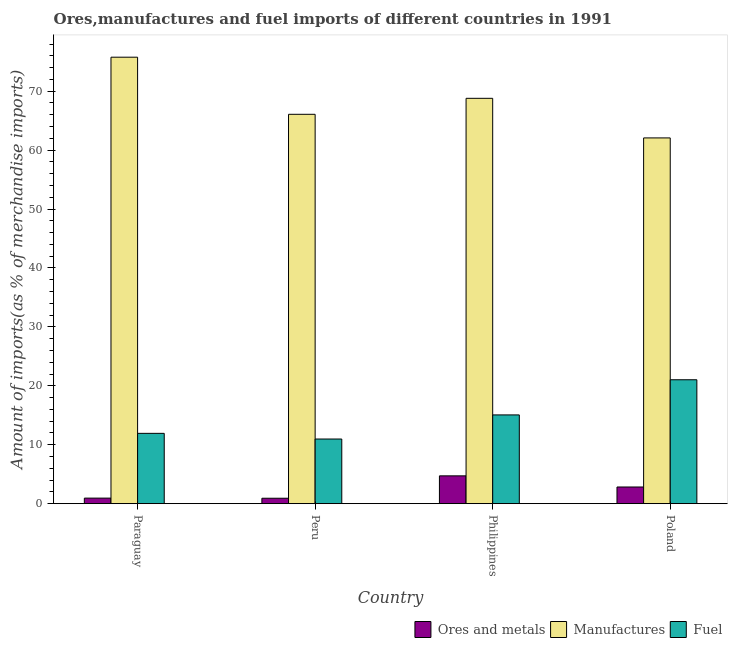Are the number of bars per tick equal to the number of legend labels?
Keep it short and to the point. Yes. How many bars are there on the 1st tick from the left?
Keep it short and to the point. 3. How many bars are there on the 2nd tick from the right?
Provide a succinct answer. 3. In how many cases, is the number of bars for a given country not equal to the number of legend labels?
Your response must be concise. 0. What is the percentage of ores and metals imports in Paraguay?
Give a very brief answer. 0.94. Across all countries, what is the maximum percentage of manufactures imports?
Your answer should be very brief. 75.77. Across all countries, what is the minimum percentage of manufactures imports?
Make the answer very short. 62.07. In which country was the percentage of ores and metals imports maximum?
Offer a very short reply. Philippines. In which country was the percentage of ores and metals imports minimum?
Keep it short and to the point. Peru. What is the total percentage of manufactures imports in the graph?
Give a very brief answer. 272.72. What is the difference between the percentage of manufactures imports in Peru and that in Poland?
Your answer should be very brief. 4. What is the difference between the percentage of ores and metals imports in Paraguay and the percentage of manufactures imports in Poland?
Keep it short and to the point. -61.13. What is the average percentage of manufactures imports per country?
Provide a short and direct response. 68.18. What is the difference between the percentage of ores and metals imports and percentage of manufactures imports in Poland?
Give a very brief answer. -59.24. In how many countries, is the percentage of ores and metals imports greater than 10 %?
Provide a succinct answer. 0. What is the ratio of the percentage of ores and metals imports in Philippines to that in Poland?
Ensure brevity in your answer.  1.67. Is the percentage of fuel imports in Paraguay less than that in Peru?
Provide a short and direct response. No. Is the difference between the percentage of ores and metals imports in Peru and Poland greater than the difference between the percentage of manufactures imports in Peru and Poland?
Your answer should be compact. No. What is the difference between the highest and the second highest percentage of ores and metals imports?
Ensure brevity in your answer.  1.89. What is the difference between the highest and the lowest percentage of fuel imports?
Provide a short and direct response. 10.06. What does the 2nd bar from the left in Philippines represents?
Provide a short and direct response. Manufactures. What does the 3rd bar from the right in Poland represents?
Provide a succinct answer. Ores and metals. Is it the case that in every country, the sum of the percentage of ores and metals imports and percentage of manufactures imports is greater than the percentage of fuel imports?
Make the answer very short. Yes. How many bars are there?
Offer a very short reply. 12. Does the graph contain any zero values?
Provide a succinct answer. No. Does the graph contain grids?
Offer a very short reply. No. Where does the legend appear in the graph?
Offer a very short reply. Bottom right. How many legend labels are there?
Your answer should be compact. 3. How are the legend labels stacked?
Your answer should be compact. Horizontal. What is the title of the graph?
Keep it short and to the point. Ores,manufactures and fuel imports of different countries in 1991. What is the label or title of the Y-axis?
Offer a very short reply. Amount of imports(as % of merchandise imports). What is the Amount of imports(as % of merchandise imports) of Ores and metals in Paraguay?
Keep it short and to the point. 0.94. What is the Amount of imports(as % of merchandise imports) in Manufactures in Paraguay?
Make the answer very short. 75.77. What is the Amount of imports(as % of merchandise imports) of Fuel in Paraguay?
Give a very brief answer. 11.93. What is the Amount of imports(as % of merchandise imports) of Ores and metals in Peru?
Provide a succinct answer. 0.92. What is the Amount of imports(as % of merchandise imports) of Manufactures in Peru?
Keep it short and to the point. 66.08. What is the Amount of imports(as % of merchandise imports) of Fuel in Peru?
Offer a terse response. 10.97. What is the Amount of imports(as % of merchandise imports) of Ores and metals in Philippines?
Make the answer very short. 4.72. What is the Amount of imports(as % of merchandise imports) in Manufactures in Philippines?
Your response must be concise. 68.79. What is the Amount of imports(as % of merchandise imports) of Fuel in Philippines?
Your answer should be compact. 15.06. What is the Amount of imports(as % of merchandise imports) of Ores and metals in Poland?
Keep it short and to the point. 2.83. What is the Amount of imports(as % of merchandise imports) in Manufactures in Poland?
Your answer should be compact. 62.07. What is the Amount of imports(as % of merchandise imports) of Fuel in Poland?
Make the answer very short. 21.03. Across all countries, what is the maximum Amount of imports(as % of merchandise imports) of Ores and metals?
Keep it short and to the point. 4.72. Across all countries, what is the maximum Amount of imports(as % of merchandise imports) in Manufactures?
Your answer should be very brief. 75.77. Across all countries, what is the maximum Amount of imports(as % of merchandise imports) in Fuel?
Give a very brief answer. 21.03. Across all countries, what is the minimum Amount of imports(as % of merchandise imports) in Ores and metals?
Offer a terse response. 0.92. Across all countries, what is the minimum Amount of imports(as % of merchandise imports) of Manufactures?
Make the answer very short. 62.07. Across all countries, what is the minimum Amount of imports(as % of merchandise imports) of Fuel?
Keep it short and to the point. 10.97. What is the total Amount of imports(as % of merchandise imports) of Ores and metals in the graph?
Ensure brevity in your answer.  9.41. What is the total Amount of imports(as % of merchandise imports) in Manufactures in the graph?
Give a very brief answer. 272.72. What is the total Amount of imports(as % of merchandise imports) of Fuel in the graph?
Ensure brevity in your answer.  58.99. What is the difference between the Amount of imports(as % of merchandise imports) of Ores and metals in Paraguay and that in Peru?
Offer a terse response. 0.02. What is the difference between the Amount of imports(as % of merchandise imports) of Manufactures in Paraguay and that in Peru?
Ensure brevity in your answer.  9.69. What is the difference between the Amount of imports(as % of merchandise imports) in Fuel in Paraguay and that in Peru?
Offer a terse response. 0.96. What is the difference between the Amount of imports(as % of merchandise imports) in Ores and metals in Paraguay and that in Philippines?
Keep it short and to the point. -3.78. What is the difference between the Amount of imports(as % of merchandise imports) in Manufactures in Paraguay and that in Philippines?
Make the answer very short. 6.98. What is the difference between the Amount of imports(as % of merchandise imports) in Fuel in Paraguay and that in Philippines?
Your answer should be very brief. -3.13. What is the difference between the Amount of imports(as % of merchandise imports) of Ores and metals in Paraguay and that in Poland?
Your response must be concise. -1.89. What is the difference between the Amount of imports(as % of merchandise imports) in Manufactures in Paraguay and that in Poland?
Offer a very short reply. 13.7. What is the difference between the Amount of imports(as % of merchandise imports) of Fuel in Paraguay and that in Poland?
Give a very brief answer. -9.1. What is the difference between the Amount of imports(as % of merchandise imports) in Ores and metals in Peru and that in Philippines?
Offer a very short reply. -3.8. What is the difference between the Amount of imports(as % of merchandise imports) of Manufactures in Peru and that in Philippines?
Ensure brevity in your answer.  -2.71. What is the difference between the Amount of imports(as % of merchandise imports) of Fuel in Peru and that in Philippines?
Ensure brevity in your answer.  -4.09. What is the difference between the Amount of imports(as % of merchandise imports) in Ores and metals in Peru and that in Poland?
Offer a very short reply. -1.91. What is the difference between the Amount of imports(as % of merchandise imports) in Manufactures in Peru and that in Poland?
Provide a succinct answer. 4. What is the difference between the Amount of imports(as % of merchandise imports) in Fuel in Peru and that in Poland?
Your response must be concise. -10.06. What is the difference between the Amount of imports(as % of merchandise imports) in Ores and metals in Philippines and that in Poland?
Make the answer very short. 1.89. What is the difference between the Amount of imports(as % of merchandise imports) in Manufactures in Philippines and that in Poland?
Offer a terse response. 6.72. What is the difference between the Amount of imports(as % of merchandise imports) of Fuel in Philippines and that in Poland?
Keep it short and to the point. -5.97. What is the difference between the Amount of imports(as % of merchandise imports) of Ores and metals in Paraguay and the Amount of imports(as % of merchandise imports) of Manufactures in Peru?
Make the answer very short. -65.14. What is the difference between the Amount of imports(as % of merchandise imports) in Ores and metals in Paraguay and the Amount of imports(as % of merchandise imports) in Fuel in Peru?
Provide a short and direct response. -10.03. What is the difference between the Amount of imports(as % of merchandise imports) in Manufactures in Paraguay and the Amount of imports(as % of merchandise imports) in Fuel in Peru?
Keep it short and to the point. 64.8. What is the difference between the Amount of imports(as % of merchandise imports) of Ores and metals in Paraguay and the Amount of imports(as % of merchandise imports) of Manufactures in Philippines?
Your answer should be very brief. -67.85. What is the difference between the Amount of imports(as % of merchandise imports) in Ores and metals in Paraguay and the Amount of imports(as % of merchandise imports) in Fuel in Philippines?
Make the answer very short. -14.12. What is the difference between the Amount of imports(as % of merchandise imports) of Manufactures in Paraguay and the Amount of imports(as % of merchandise imports) of Fuel in Philippines?
Give a very brief answer. 60.71. What is the difference between the Amount of imports(as % of merchandise imports) of Ores and metals in Paraguay and the Amount of imports(as % of merchandise imports) of Manufactures in Poland?
Make the answer very short. -61.13. What is the difference between the Amount of imports(as % of merchandise imports) in Ores and metals in Paraguay and the Amount of imports(as % of merchandise imports) in Fuel in Poland?
Offer a terse response. -20.09. What is the difference between the Amount of imports(as % of merchandise imports) of Manufactures in Paraguay and the Amount of imports(as % of merchandise imports) of Fuel in Poland?
Your answer should be very brief. 54.74. What is the difference between the Amount of imports(as % of merchandise imports) in Ores and metals in Peru and the Amount of imports(as % of merchandise imports) in Manufactures in Philippines?
Offer a very short reply. -67.88. What is the difference between the Amount of imports(as % of merchandise imports) in Ores and metals in Peru and the Amount of imports(as % of merchandise imports) in Fuel in Philippines?
Provide a succinct answer. -14.14. What is the difference between the Amount of imports(as % of merchandise imports) in Manufactures in Peru and the Amount of imports(as % of merchandise imports) in Fuel in Philippines?
Ensure brevity in your answer.  51.02. What is the difference between the Amount of imports(as % of merchandise imports) in Ores and metals in Peru and the Amount of imports(as % of merchandise imports) in Manufactures in Poland?
Give a very brief answer. -61.16. What is the difference between the Amount of imports(as % of merchandise imports) in Ores and metals in Peru and the Amount of imports(as % of merchandise imports) in Fuel in Poland?
Your answer should be very brief. -20.11. What is the difference between the Amount of imports(as % of merchandise imports) of Manufactures in Peru and the Amount of imports(as % of merchandise imports) of Fuel in Poland?
Offer a very short reply. 45.05. What is the difference between the Amount of imports(as % of merchandise imports) of Ores and metals in Philippines and the Amount of imports(as % of merchandise imports) of Manufactures in Poland?
Give a very brief answer. -57.35. What is the difference between the Amount of imports(as % of merchandise imports) of Ores and metals in Philippines and the Amount of imports(as % of merchandise imports) of Fuel in Poland?
Offer a very short reply. -16.31. What is the difference between the Amount of imports(as % of merchandise imports) in Manufactures in Philippines and the Amount of imports(as % of merchandise imports) in Fuel in Poland?
Give a very brief answer. 47.76. What is the average Amount of imports(as % of merchandise imports) in Ores and metals per country?
Provide a succinct answer. 2.35. What is the average Amount of imports(as % of merchandise imports) of Manufactures per country?
Your answer should be compact. 68.18. What is the average Amount of imports(as % of merchandise imports) in Fuel per country?
Give a very brief answer. 14.75. What is the difference between the Amount of imports(as % of merchandise imports) of Ores and metals and Amount of imports(as % of merchandise imports) of Manufactures in Paraguay?
Offer a very short reply. -74.83. What is the difference between the Amount of imports(as % of merchandise imports) of Ores and metals and Amount of imports(as % of merchandise imports) of Fuel in Paraguay?
Offer a very short reply. -10.99. What is the difference between the Amount of imports(as % of merchandise imports) of Manufactures and Amount of imports(as % of merchandise imports) of Fuel in Paraguay?
Keep it short and to the point. 63.84. What is the difference between the Amount of imports(as % of merchandise imports) of Ores and metals and Amount of imports(as % of merchandise imports) of Manufactures in Peru?
Ensure brevity in your answer.  -65.16. What is the difference between the Amount of imports(as % of merchandise imports) in Ores and metals and Amount of imports(as % of merchandise imports) in Fuel in Peru?
Your response must be concise. -10.05. What is the difference between the Amount of imports(as % of merchandise imports) of Manufactures and Amount of imports(as % of merchandise imports) of Fuel in Peru?
Your response must be concise. 55.11. What is the difference between the Amount of imports(as % of merchandise imports) of Ores and metals and Amount of imports(as % of merchandise imports) of Manufactures in Philippines?
Offer a very short reply. -64.07. What is the difference between the Amount of imports(as % of merchandise imports) in Ores and metals and Amount of imports(as % of merchandise imports) in Fuel in Philippines?
Ensure brevity in your answer.  -10.34. What is the difference between the Amount of imports(as % of merchandise imports) in Manufactures and Amount of imports(as % of merchandise imports) in Fuel in Philippines?
Provide a succinct answer. 53.73. What is the difference between the Amount of imports(as % of merchandise imports) of Ores and metals and Amount of imports(as % of merchandise imports) of Manufactures in Poland?
Give a very brief answer. -59.24. What is the difference between the Amount of imports(as % of merchandise imports) in Ores and metals and Amount of imports(as % of merchandise imports) in Fuel in Poland?
Provide a succinct answer. -18.2. What is the difference between the Amount of imports(as % of merchandise imports) of Manufactures and Amount of imports(as % of merchandise imports) of Fuel in Poland?
Ensure brevity in your answer.  41.04. What is the ratio of the Amount of imports(as % of merchandise imports) of Ores and metals in Paraguay to that in Peru?
Your answer should be compact. 1.02. What is the ratio of the Amount of imports(as % of merchandise imports) in Manufactures in Paraguay to that in Peru?
Offer a terse response. 1.15. What is the ratio of the Amount of imports(as % of merchandise imports) of Fuel in Paraguay to that in Peru?
Your response must be concise. 1.09. What is the ratio of the Amount of imports(as % of merchandise imports) in Ores and metals in Paraguay to that in Philippines?
Offer a terse response. 0.2. What is the ratio of the Amount of imports(as % of merchandise imports) in Manufactures in Paraguay to that in Philippines?
Ensure brevity in your answer.  1.1. What is the ratio of the Amount of imports(as % of merchandise imports) of Fuel in Paraguay to that in Philippines?
Your response must be concise. 0.79. What is the ratio of the Amount of imports(as % of merchandise imports) of Ores and metals in Paraguay to that in Poland?
Ensure brevity in your answer.  0.33. What is the ratio of the Amount of imports(as % of merchandise imports) of Manufactures in Paraguay to that in Poland?
Ensure brevity in your answer.  1.22. What is the ratio of the Amount of imports(as % of merchandise imports) in Fuel in Paraguay to that in Poland?
Your answer should be compact. 0.57. What is the ratio of the Amount of imports(as % of merchandise imports) in Ores and metals in Peru to that in Philippines?
Ensure brevity in your answer.  0.19. What is the ratio of the Amount of imports(as % of merchandise imports) in Manufactures in Peru to that in Philippines?
Offer a terse response. 0.96. What is the ratio of the Amount of imports(as % of merchandise imports) in Fuel in Peru to that in Philippines?
Provide a short and direct response. 0.73. What is the ratio of the Amount of imports(as % of merchandise imports) in Ores and metals in Peru to that in Poland?
Give a very brief answer. 0.32. What is the ratio of the Amount of imports(as % of merchandise imports) in Manufactures in Peru to that in Poland?
Provide a succinct answer. 1.06. What is the ratio of the Amount of imports(as % of merchandise imports) in Fuel in Peru to that in Poland?
Give a very brief answer. 0.52. What is the ratio of the Amount of imports(as % of merchandise imports) in Ores and metals in Philippines to that in Poland?
Provide a short and direct response. 1.67. What is the ratio of the Amount of imports(as % of merchandise imports) in Manufactures in Philippines to that in Poland?
Your response must be concise. 1.11. What is the ratio of the Amount of imports(as % of merchandise imports) in Fuel in Philippines to that in Poland?
Offer a terse response. 0.72. What is the difference between the highest and the second highest Amount of imports(as % of merchandise imports) of Ores and metals?
Offer a terse response. 1.89. What is the difference between the highest and the second highest Amount of imports(as % of merchandise imports) of Manufactures?
Ensure brevity in your answer.  6.98. What is the difference between the highest and the second highest Amount of imports(as % of merchandise imports) of Fuel?
Make the answer very short. 5.97. What is the difference between the highest and the lowest Amount of imports(as % of merchandise imports) in Ores and metals?
Ensure brevity in your answer.  3.8. What is the difference between the highest and the lowest Amount of imports(as % of merchandise imports) of Manufactures?
Your response must be concise. 13.7. What is the difference between the highest and the lowest Amount of imports(as % of merchandise imports) in Fuel?
Provide a short and direct response. 10.06. 